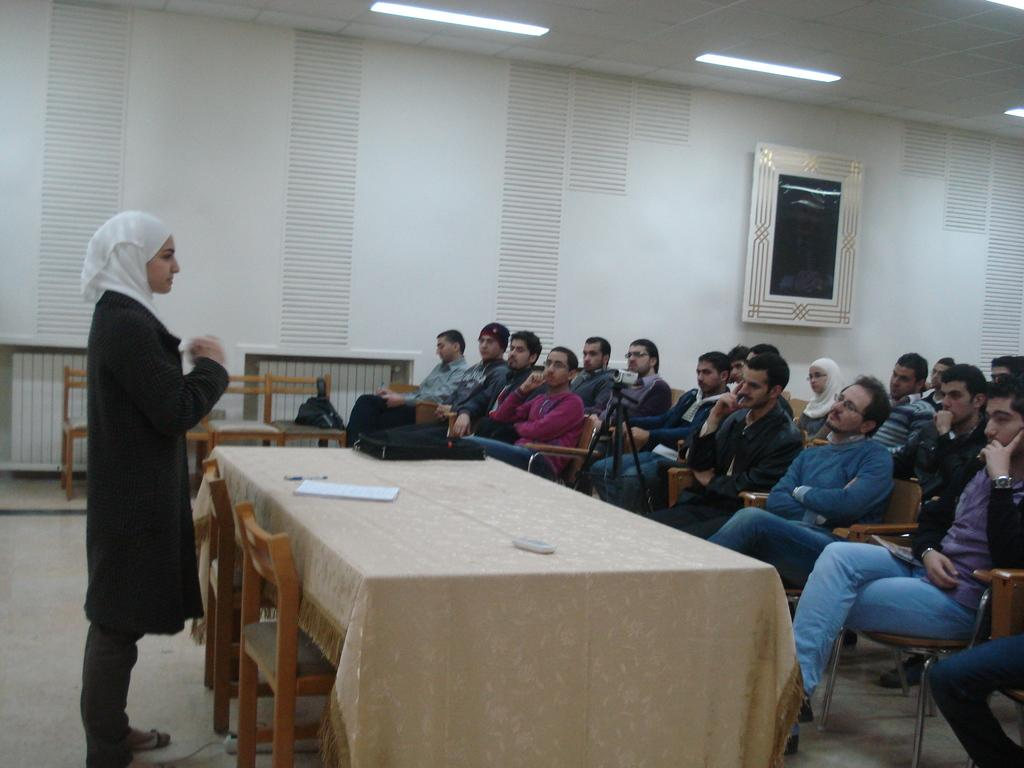What are the people in the image doing? The people in the image are sitting on chairs. What is the woman in the image doing? The woman is standing in front of the people. What is the interaction between the people and the woman? The people and the woman are looking at each other. What type of root can be seen growing from the chair in the image? There is no root growing from the chair in the image; it is a regular chair. 